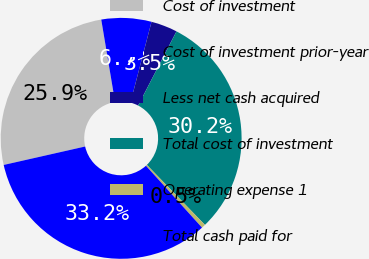Convert chart. <chart><loc_0><loc_0><loc_500><loc_500><pie_chart><fcel>Cost of investment<fcel>Cost of investment prior-year<fcel>Less net cash acquired<fcel>Total cost of investment<fcel>Operating expense 1<fcel>Total cash paid for<nl><fcel>25.9%<fcel>6.7%<fcel>3.54%<fcel>30.16%<fcel>0.53%<fcel>33.17%<nl></chart> 